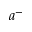<formula> <loc_0><loc_0><loc_500><loc_500>a ^ { - }</formula> 